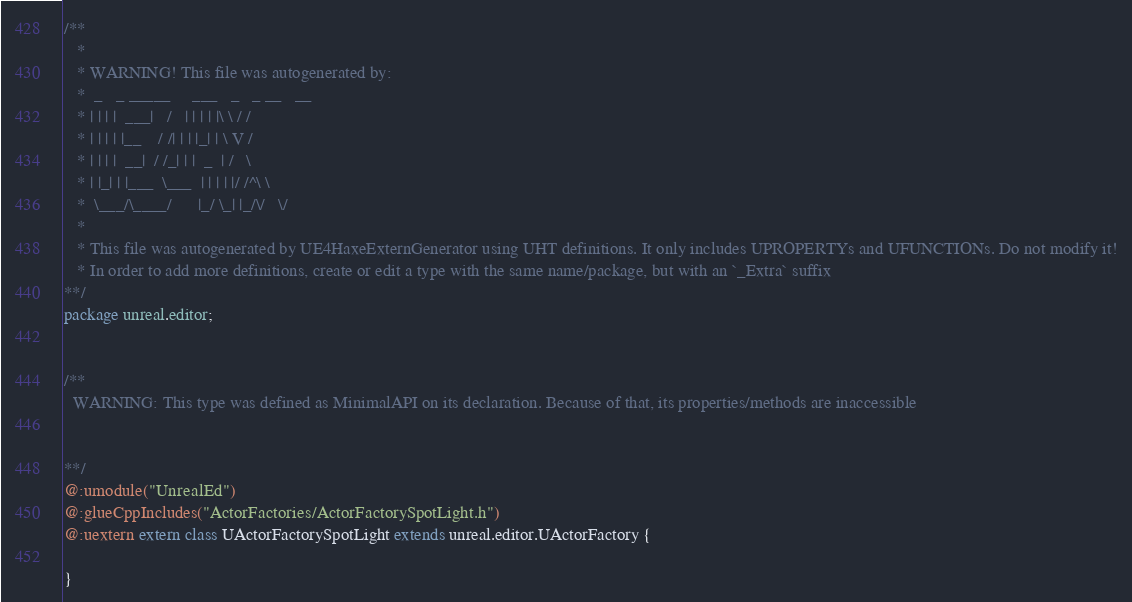<code> <loc_0><loc_0><loc_500><loc_500><_Haxe_>/**
   * 
   * WARNING! This file was autogenerated by: 
   *  _   _ _____     ___   _   _ __   __ 
   * | | | |  ___|   /   | | | | |\ \ / / 
   * | | | | |__    / /| | | |_| | \ V /  
   * | | | |  __|  / /_| | |  _  | /   \  
   * | |_| | |___  \___  | | | | |/ /^\ \ 
   *  \___/\____/      |_/ \_| |_/\/   \/ 
   * 
   * This file was autogenerated by UE4HaxeExternGenerator using UHT definitions. It only includes UPROPERTYs and UFUNCTIONs. Do not modify it!
   * In order to add more definitions, create or edit a type with the same name/package, but with an `_Extra` suffix
**/
package unreal.editor;


/**
  WARNING: This type was defined as MinimalAPI on its declaration. Because of that, its properties/methods are inaccessible
  
  
**/
@:umodule("UnrealEd")
@:glueCppIncludes("ActorFactories/ActorFactorySpotLight.h")
@:uextern extern class UActorFactorySpotLight extends unreal.editor.UActorFactory {
  
}
</code> 